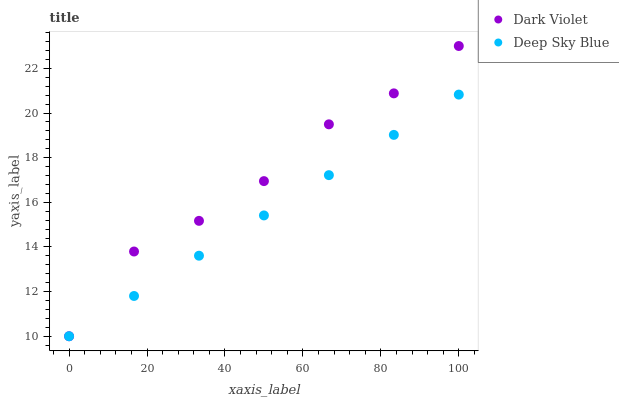Does Deep Sky Blue have the minimum area under the curve?
Answer yes or no. Yes. Does Dark Violet have the maximum area under the curve?
Answer yes or no. Yes. Does Dark Violet have the minimum area under the curve?
Answer yes or no. No. Is Deep Sky Blue the smoothest?
Answer yes or no. Yes. Is Dark Violet the roughest?
Answer yes or no. Yes. Is Dark Violet the smoothest?
Answer yes or no. No. Does Deep Sky Blue have the lowest value?
Answer yes or no. Yes. Does Dark Violet have the highest value?
Answer yes or no. Yes. Does Deep Sky Blue intersect Dark Violet?
Answer yes or no. Yes. Is Deep Sky Blue less than Dark Violet?
Answer yes or no. No. Is Deep Sky Blue greater than Dark Violet?
Answer yes or no. No. 